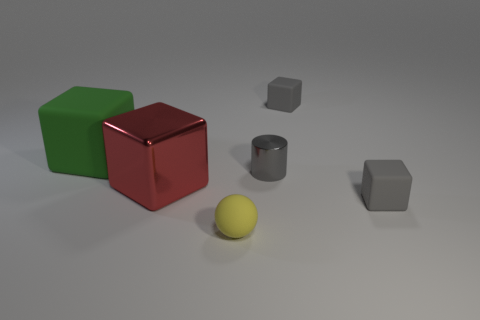Subtract all big green rubber cubes. How many cubes are left? 3 Subtract all green cubes. How many cubes are left? 3 Add 3 red shiny spheres. How many objects exist? 9 Subtract all balls. How many objects are left? 5 Subtract all yellow cylinders. Subtract all gray shiny objects. How many objects are left? 5 Add 4 small gray cylinders. How many small gray cylinders are left? 5 Add 6 large matte things. How many large matte things exist? 7 Subtract 0 green balls. How many objects are left? 6 Subtract 1 cylinders. How many cylinders are left? 0 Subtract all blue blocks. Subtract all brown spheres. How many blocks are left? 4 